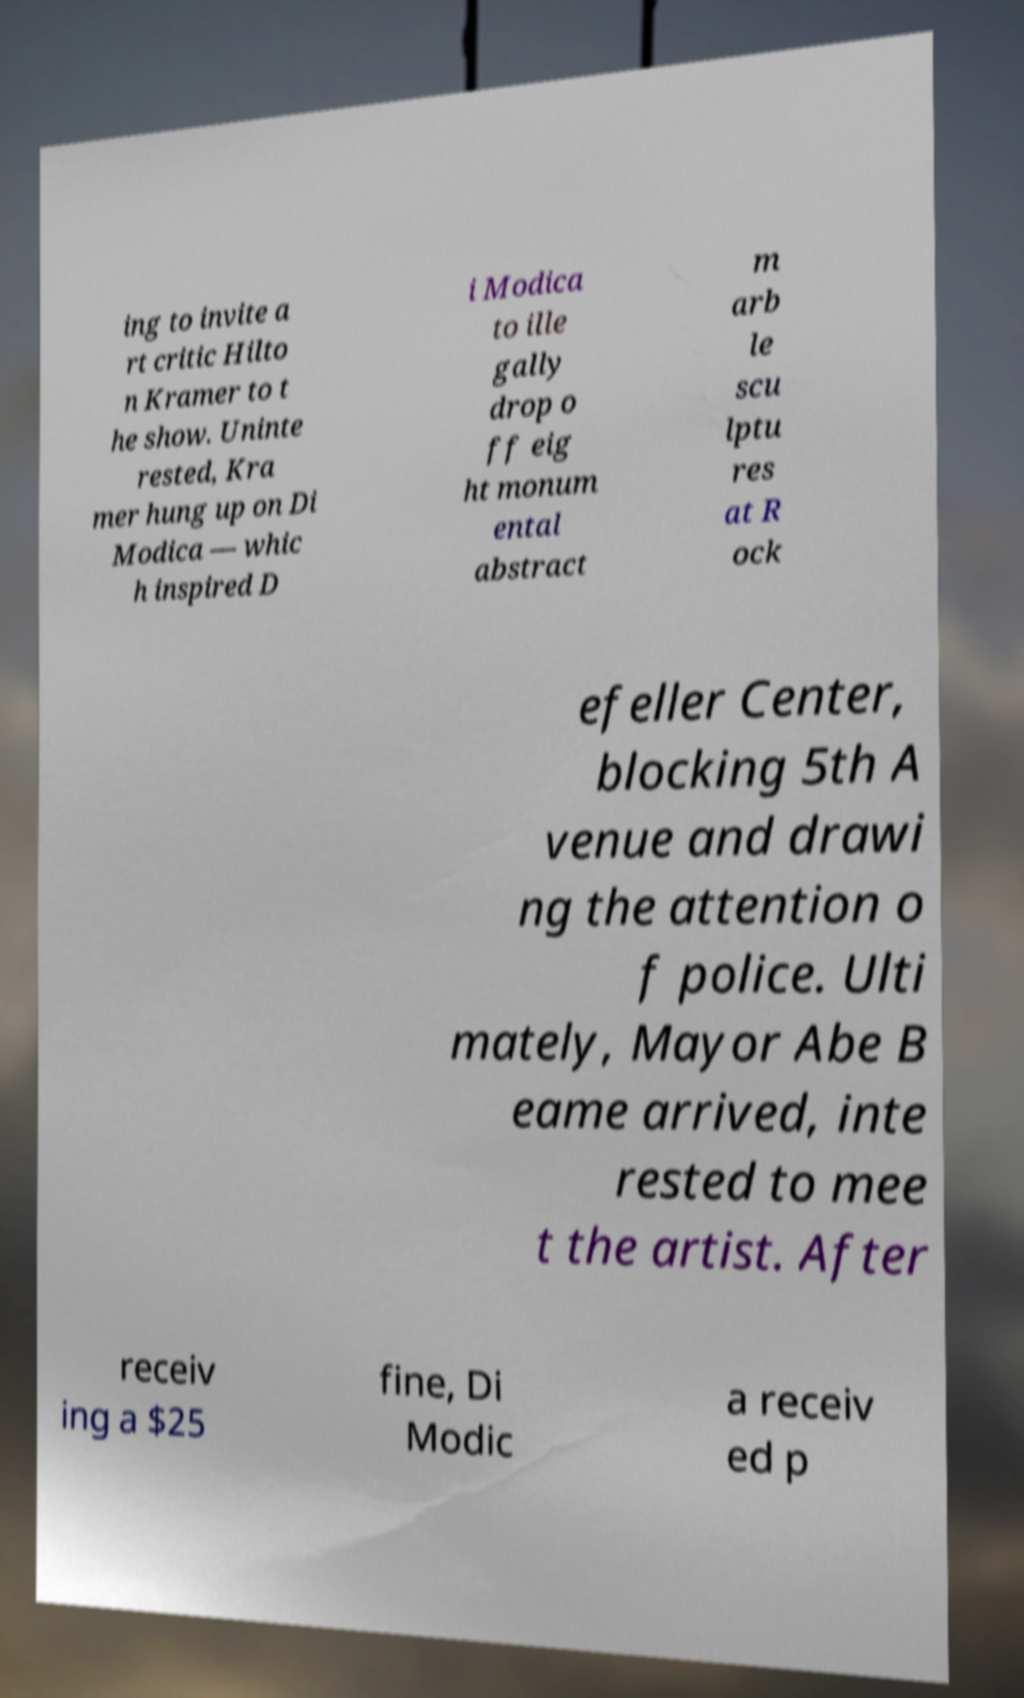Please identify and transcribe the text found in this image. ing to invite a rt critic Hilto n Kramer to t he show. Uninte rested, Kra mer hung up on Di Modica — whic h inspired D i Modica to ille gally drop o ff eig ht monum ental abstract m arb le scu lptu res at R ock efeller Center, blocking 5th A venue and drawi ng the attention o f police. Ulti mately, Mayor Abe B eame arrived, inte rested to mee t the artist. After receiv ing a $25 fine, Di Modic a receiv ed p 